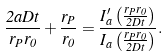<formula> <loc_0><loc_0><loc_500><loc_500>\frac { 2 a D t } { r _ { P } r _ { 0 } } + \frac { r _ { P } } { r _ { 0 } } = \frac { I ^ { \prime } _ { a } \left ( \frac { r _ { P } r _ { 0 } } { 2 D t } \right ) } { I _ { a } \left ( \frac { r _ { P } r _ { 0 } } { 2 D t } \right ) } .</formula> 